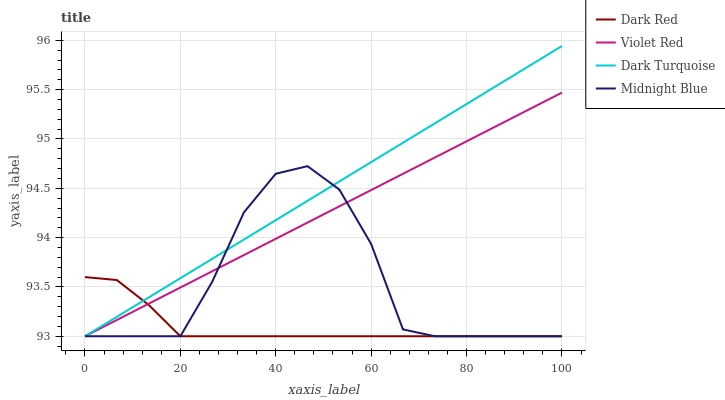Does Violet Red have the minimum area under the curve?
Answer yes or no. No. Does Violet Red have the maximum area under the curve?
Answer yes or no. No. Is Violet Red the smoothest?
Answer yes or no. No. Is Violet Red the roughest?
Answer yes or no. No. Does Violet Red have the highest value?
Answer yes or no. No. 